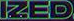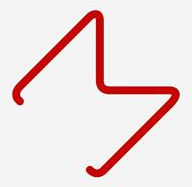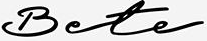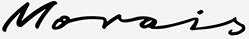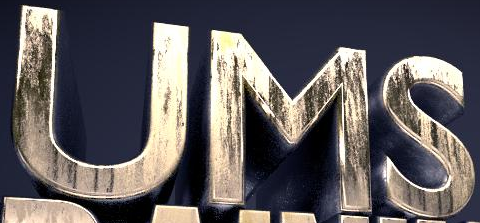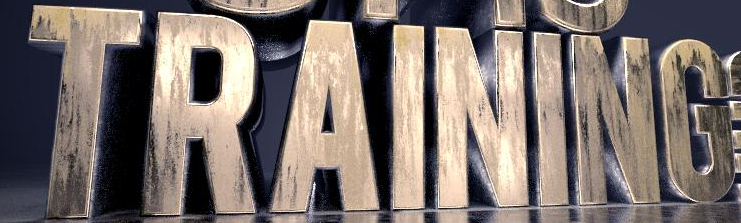Transcribe the words shown in these images in order, separated by a semicolon. IZED; M; Bete; Morois; UMS; TRAINING 